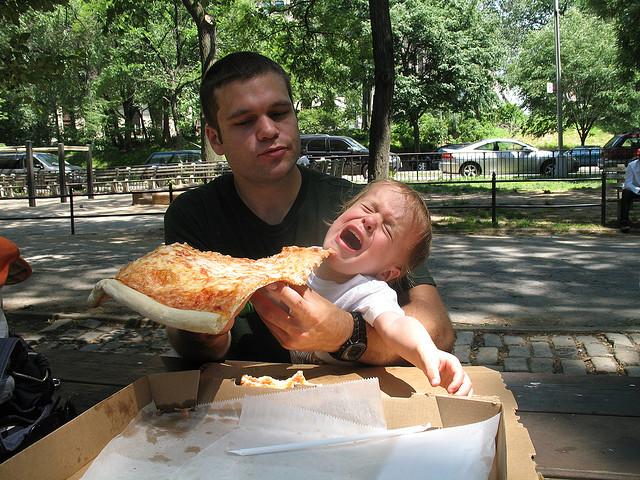Is the child happy about eating?
Give a very brief answer. No. How many cars are red?
Answer briefly. 0. What is wrong with this child?
Concise answer only. Crying. 